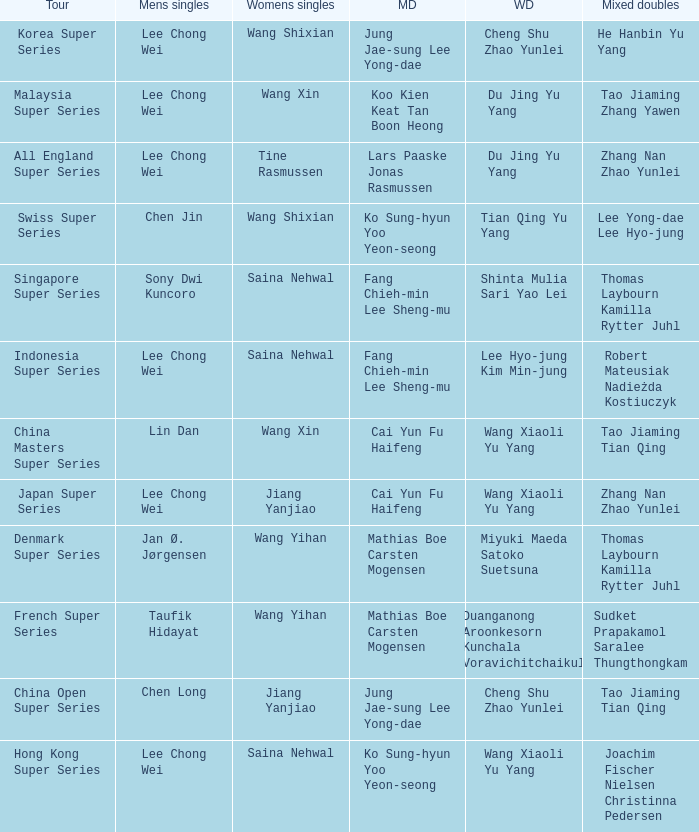Who is the mixed doubled on the tour korea super series? He Hanbin Yu Yang. 